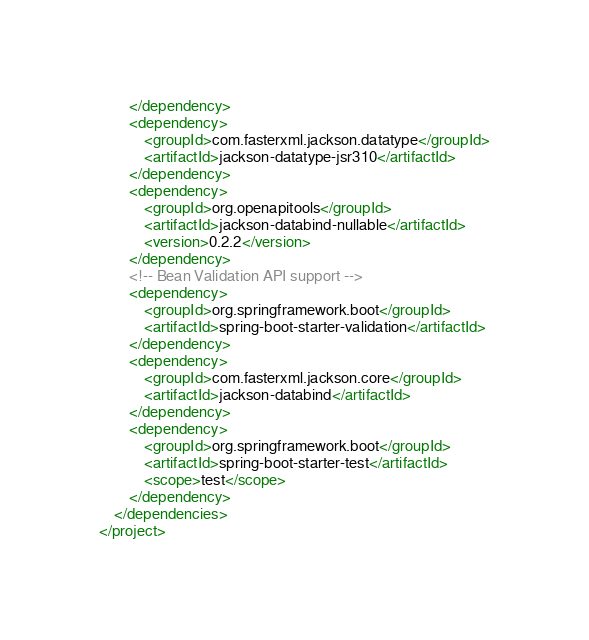<code> <loc_0><loc_0><loc_500><loc_500><_XML_>        </dependency>
        <dependency>
            <groupId>com.fasterxml.jackson.datatype</groupId>
            <artifactId>jackson-datatype-jsr310</artifactId>
        </dependency>
        <dependency>
            <groupId>org.openapitools</groupId>
            <artifactId>jackson-databind-nullable</artifactId>
            <version>0.2.2</version>
        </dependency>
        <!-- Bean Validation API support -->
        <dependency>
            <groupId>org.springframework.boot</groupId>
            <artifactId>spring-boot-starter-validation</artifactId>
        </dependency>
        <dependency>
            <groupId>com.fasterxml.jackson.core</groupId>
            <artifactId>jackson-databind</artifactId>
        </dependency>
        <dependency>
            <groupId>org.springframework.boot</groupId>
            <artifactId>spring-boot-starter-test</artifactId>
            <scope>test</scope>
        </dependency>
    </dependencies>
</project>
</code> 